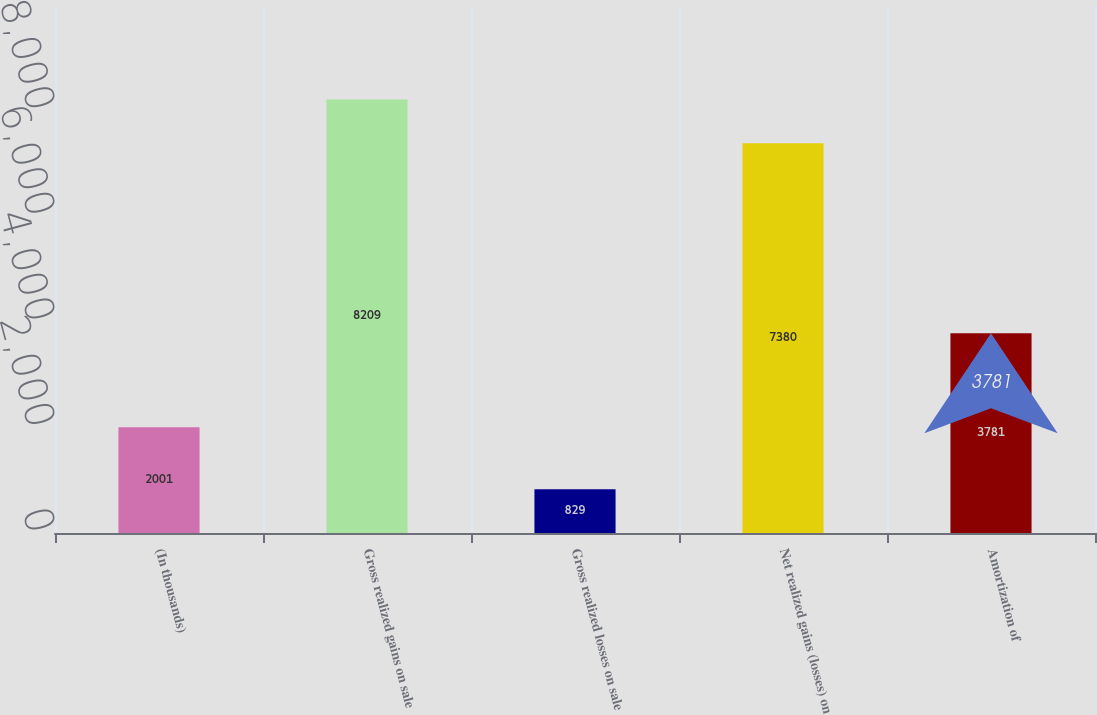<chart> <loc_0><loc_0><loc_500><loc_500><bar_chart><fcel>(In thousands)<fcel>Gross realized gains on sale<fcel>Gross realized losses on sale<fcel>Net realized gains (losses) on<fcel>Amortization of<nl><fcel>2001<fcel>8209<fcel>829<fcel>7380<fcel>3781<nl></chart> 